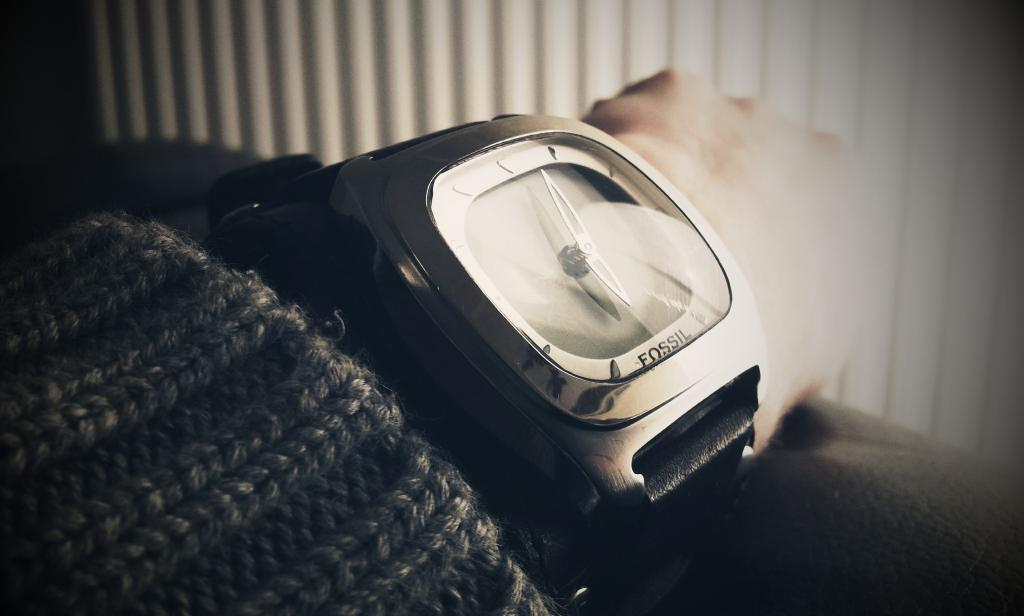<image>
Provide a brief description of the given image. A man wearing a knitted sweater also has on a Fossil wrist watch. 